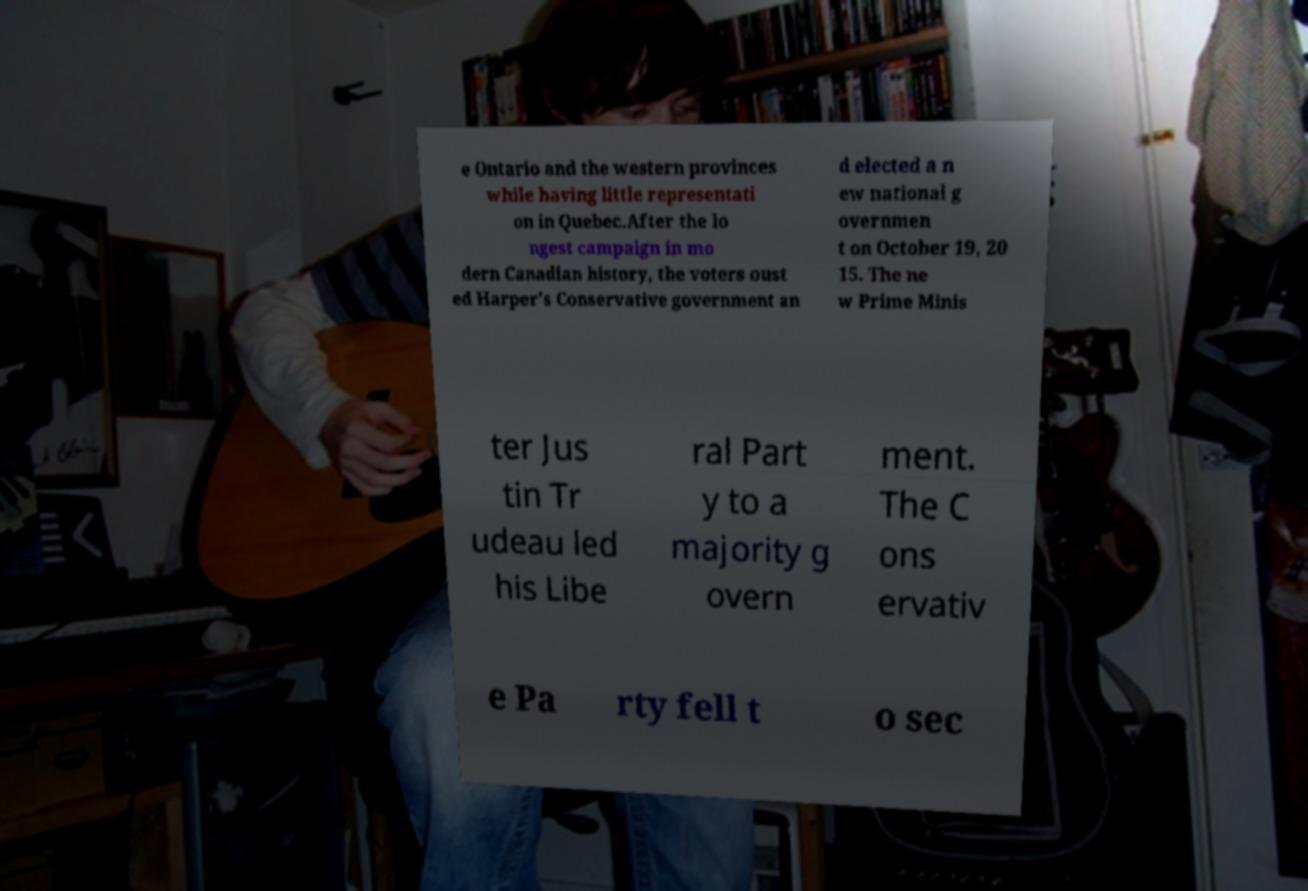Can you accurately transcribe the text from the provided image for me? e Ontario and the western provinces while having little representati on in Quebec.After the lo ngest campaign in mo dern Canadian history, the voters oust ed Harper's Conservative government an d elected a n ew national g overnmen t on October 19, 20 15. The ne w Prime Minis ter Jus tin Tr udeau led his Libe ral Part y to a majority g overn ment. The C ons ervativ e Pa rty fell t o sec 